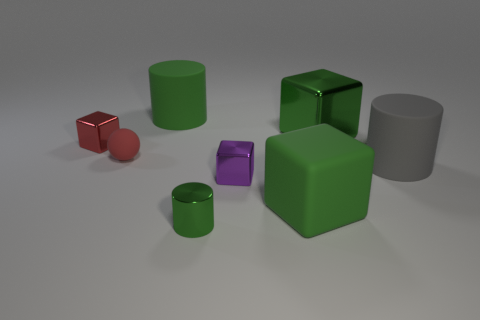What is the color of the cylinder that is both behind the small purple metal block and left of the gray thing?
Give a very brief answer. Green. Are there more big green rubber blocks in front of the red block than matte cylinders on the left side of the large green cylinder?
Provide a succinct answer. Yes. Does the rubber object that is behind the red metallic block have the same size as the small purple cube?
Provide a succinct answer. No. There is a ball behind the green rubber block that is on the right side of the green metal cylinder; what number of large green objects are in front of it?
Your answer should be very brief. 1. What is the size of the green object that is behind the tiny sphere and to the left of the small purple shiny thing?
Ensure brevity in your answer.  Large. How many other things are there of the same shape as the purple metallic thing?
Give a very brief answer. 3. There is a big gray cylinder; what number of metal cylinders are to the left of it?
Provide a short and direct response. 1. Is the number of green shiny blocks that are in front of the tiny green shiny cylinder less than the number of red balls to the left of the green metallic block?
Provide a succinct answer. Yes. The green metal thing that is behind the green metal cylinder that is on the left side of the small cube to the right of the red rubber object is what shape?
Make the answer very short. Cube. There is a thing that is both right of the small red sphere and on the left side of the tiny cylinder; what shape is it?
Give a very brief answer. Cylinder. 